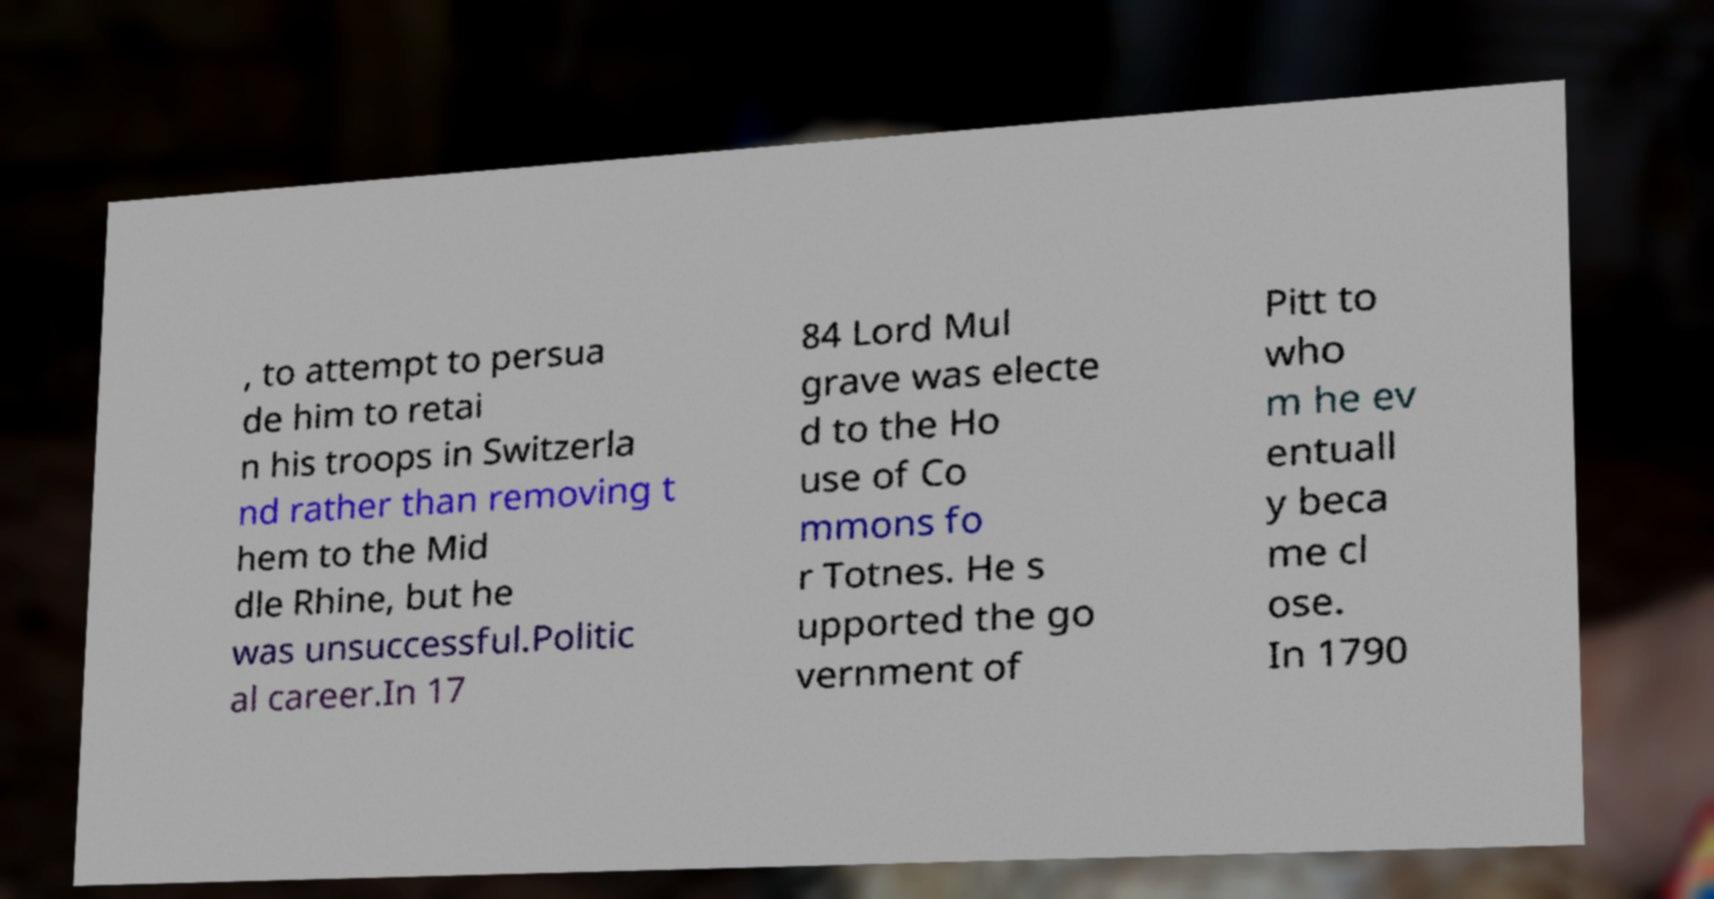Could you assist in decoding the text presented in this image and type it out clearly? , to attempt to persua de him to retai n his troops in Switzerla nd rather than removing t hem to the Mid dle Rhine, but he was unsuccessful.Politic al career.In 17 84 Lord Mul grave was electe d to the Ho use of Co mmons fo r Totnes. He s upported the go vernment of Pitt to who m he ev entuall y beca me cl ose. In 1790 